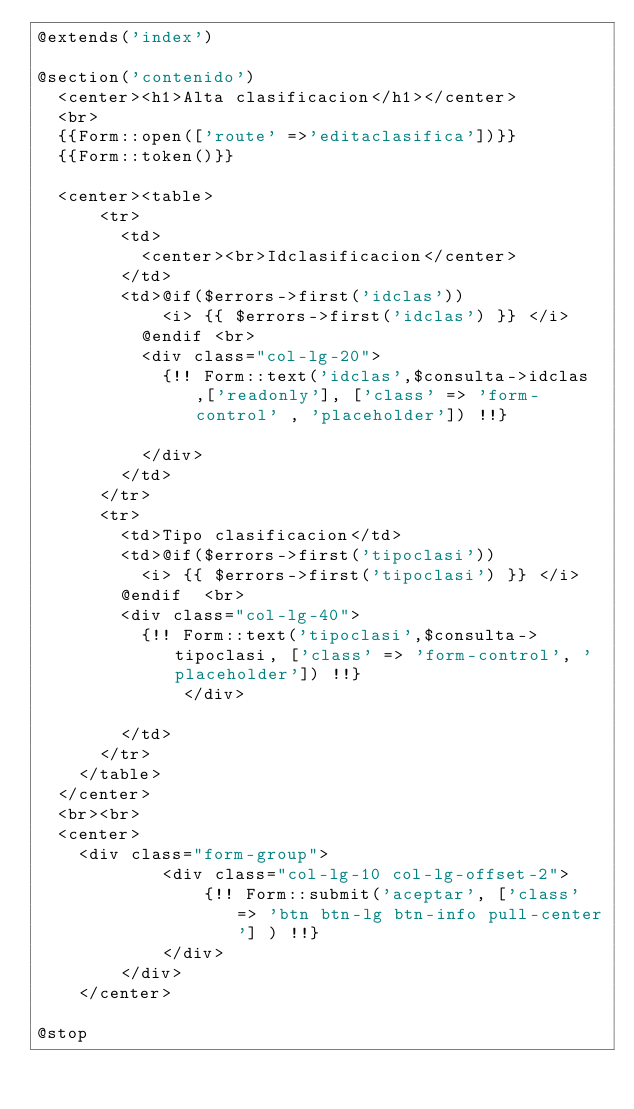Convert code to text. <code><loc_0><loc_0><loc_500><loc_500><_PHP_>@extends('index')

@section('contenido')
	<center><h1>Alta clasificacion</h1></center>
	<br>
	{{Form::open(['route' =>'editaclasifica'])}}
	{{Form::token()}}

	<center><table>
			<tr>
				<td>
					<center><br>Idclasificacion</center>
				</td>
				<td>@if($errors->first('idclas'))
						<i> {{ $errors->first('idclas') }} </i>
					@endif <br>	
					<div class="col-lg-20">
						{!! Form::text('idclas',$consulta->idclas,['readonly'], ['class' => 'form-control' , 'placeholder']) !!}
						
					</div>		
				</td>
			</tr>
			<tr>
				<td>Tipo clasificacion</td>
				<td>@if($errors->first('tipoclasi'))
					<i> {{ $errors->first('tipoclasi') }} </i>
				@endif 	<br>
				<div class="col-lg-40">
					{!! Form::text('tipoclasi',$consulta->tipoclasi, ['class' => 'form-control', 'placeholder']) !!}
           	 	</div>
					
				</td>
			</tr>
		</table>
	</center>
	<br><br>
	<center>
		<div class="form-group">
            <div class="col-lg-10 col-lg-offset-2">
                {!! Form::submit('aceptar', ['class' => 'btn btn-lg btn-info pull-center'] ) !!}
            </div>
        </div>
    </center>

@stop</code> 